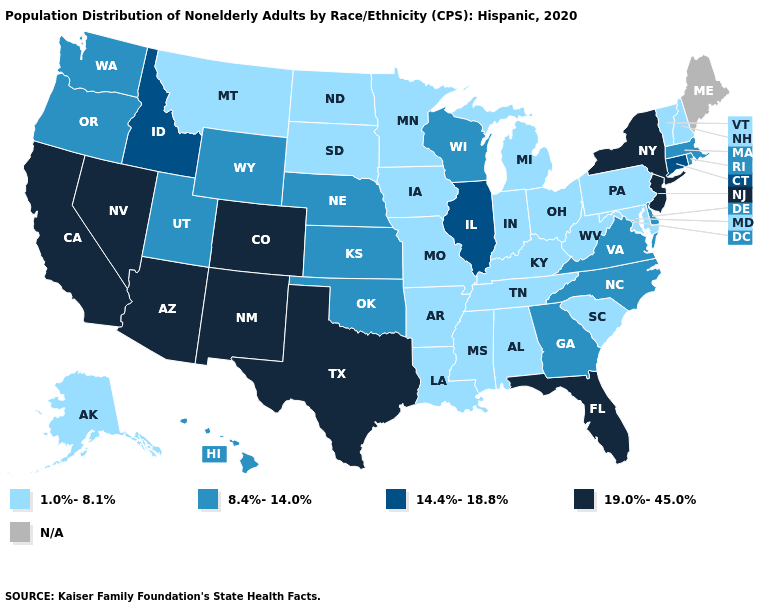Among the states that border California , which have the highest value?
Keep it brief. Arizona, Nevada. What is the value of Missouri?
Short answer required. 1.0%-8.1%. Which states have the highest value in the USA?
Be succinct. Arizona, California, Colorado, Florida, Nevada, New Jersey, New Mexico, New York, Texas. What is the value of Nevada?
Be succinct. 19.0%-45.0%. Name the states that have a value in the range 1.0%-8.1%?
Be succinct. Alabama, Alaska, Arkansas, Indiana, Iowa, Kentucky, Louisiana, Maryland, Michigan, Minnesota, Mississippi, Missouri, Montana, New Hampshire, North Dakota, Ohio, Pennsylvania, South Carolina, South Dakota, Tennessee, Vermont, West Virginia. Among the states that border Tennessee , which have the highest value?
Keep it brief. Georgia, North Carolina, Virginia. Name the states that have a value in the range N/A?
Be succinct. Maine. Does Florida have the highest value in the USA?
Short answer required. Yes. Does the map have missing data?
Concise answer only. Yes. Which states hav the highest value in the South?
Write a very short answer. Florida, Texas. What is the value of Nevada?
Keep it brief. 19.0%-45.0%. Which states hav the highest value in the Northeast?
Concise answer only. New Jersey, New York. Name the states that have a value in the range 19.0%-45.0%?
Give a very brief answer. Arizona, California, Colorado, Florida, Nevada, New Jersey, New Mexico, New York, Texas. What is the value of Ohio?
Write a very short answer. 1.0%-8.1%. What is the value of Louisiana?
Keep it brief. 1.0%-8.1%. 